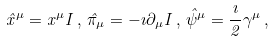Convert formula to latex. <formula><loc_0><loc_0><loc_500><loc_500>\hat { x } ^ { \mu } = x ^ { \mu } { I } \, , \, \hat { \pi } _ { \mu } = - \imath \partial _ { \mu } { I } \, , \, \hat { \psi } ^ { \mu } = \frac { \imath } { 2 } \gamma ^ { \mu } \, ,</formula> 